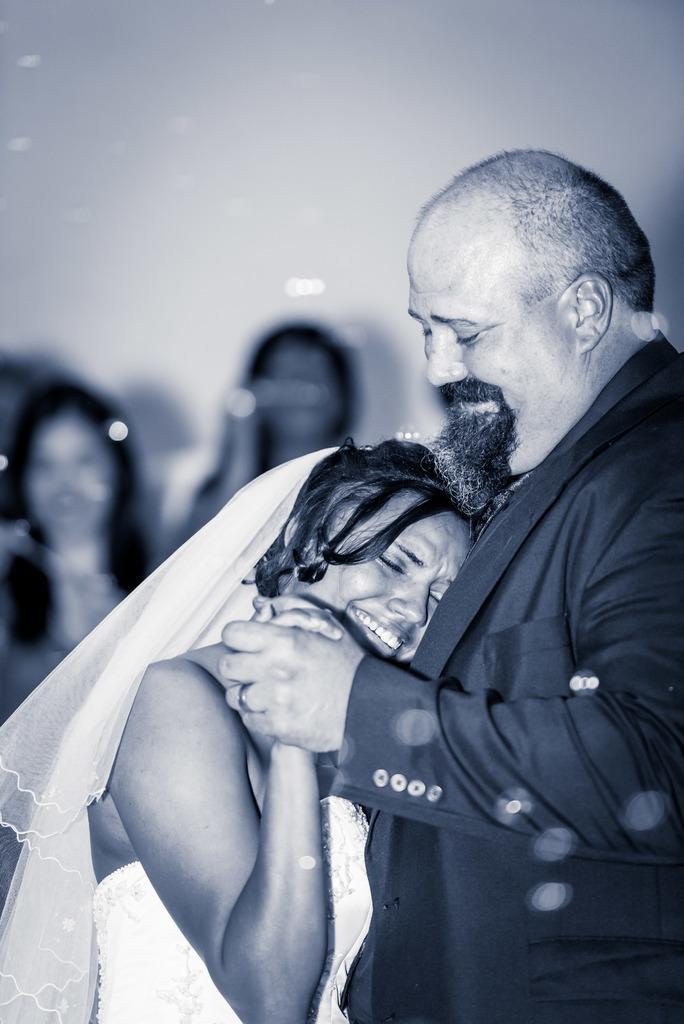In one or two sentences, can you explain what this image depicts? This image consists of a man wearing a black suit. In front of him, there is a woman wearing a white dress is crying. In the background there are few people. And the background is blurred. 